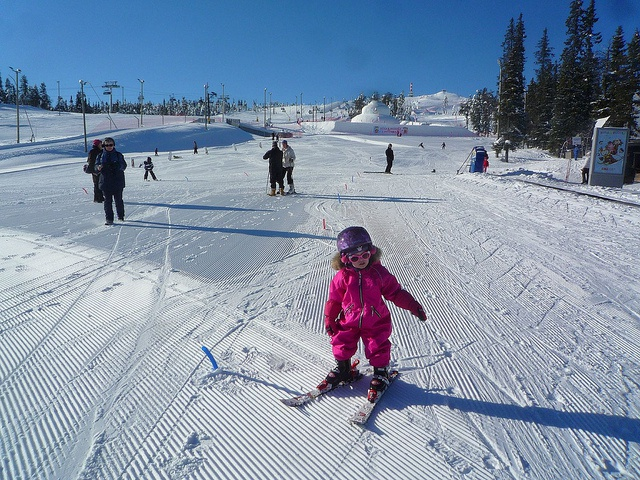Describe the objects in this image and their specific colors. I can see people in gray, purple, and black tones, people in gray, black, navy, and darkgray tones, people in gray, darkgray, and blue tones, skis in gray, darkgray, and lightgray tones, and people in gray, black, darkgray, and lightgray tones in this image. 